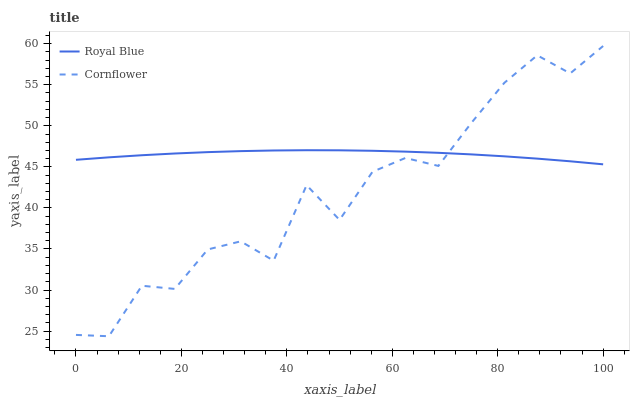Does Cornflower have the minimum area under the curve?
Answer yes or no. Yes. Does Royal Blue have the maximum area under the curve?
Answer yes or no. Yes. Does Cornflower have the maximum area under the curve?
Answer yes or no. No. Is Royal Blue the smoothest?
Answer yes or no. Yes. Is Cornflower the roughest?
Answer yes or no. Yes. Is Cornflower the smoothest?
Answer yes or no. No. Does Cornflower have the lowest value?
Answer yes or no. Yes. Does Cornflower have the highest value?
Answer yes or no. Yes. Does Cornflower intersect Royal Blue?
Answer yes or no. Yes. Is Cornflower less than Royal Blue?
Answer yes or no. No. Is Cornflower greater than Royal Blue?
Answer yes or no. No. 